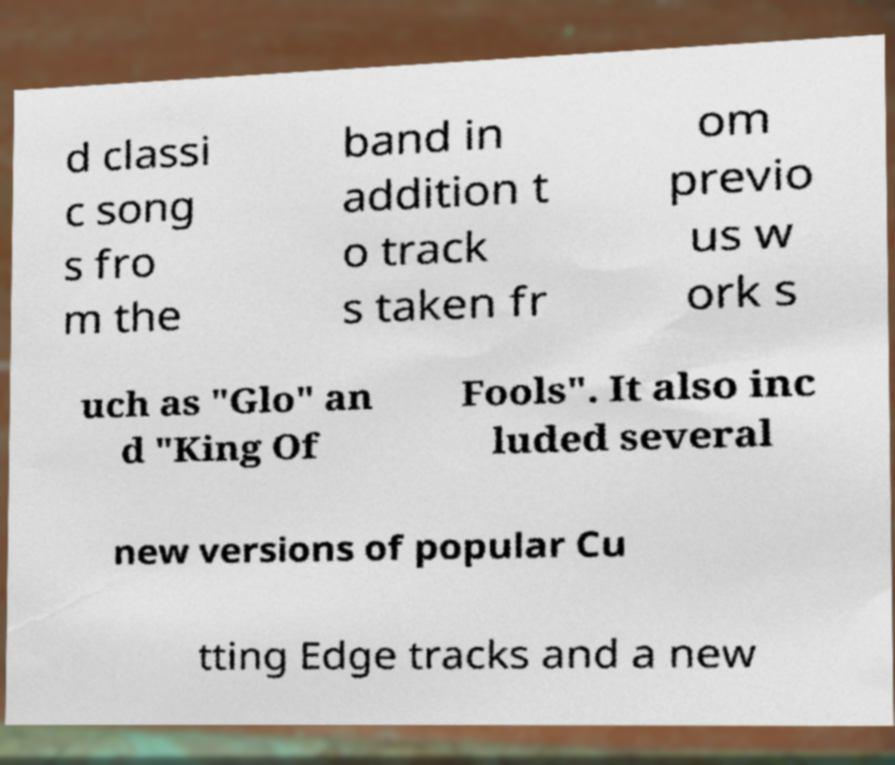Could you assist in decoding the text presented in this image and type it out clearly? d classi c song s fro m the band in addition t o track s taken fr om previo us w ork s uch as "Glo" an d "King Of Fools". It also inc luded several new versions of popular Cu tting Edge tracks and a new 